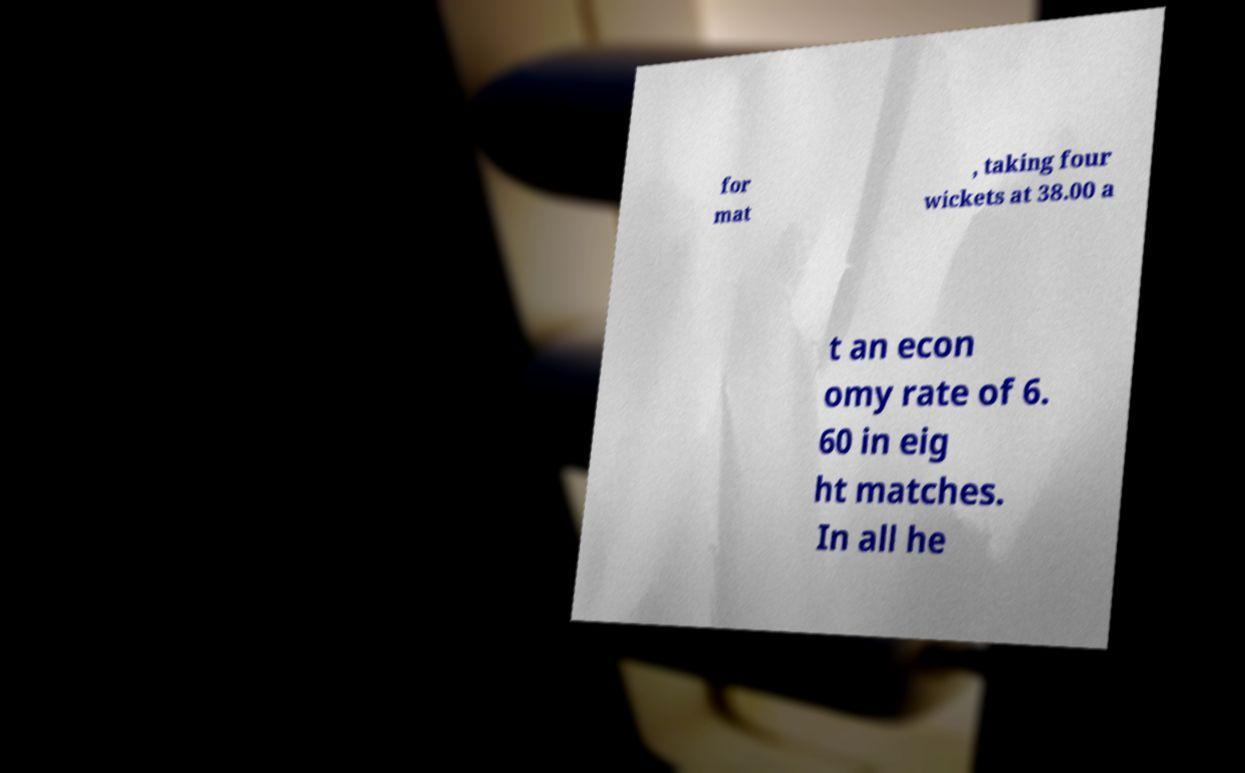Could you extract and type out the text from this image? for mat , taking four wickets at 38.00 a t an econ omy rate of 6. 60 in eig ht matches. In all he 